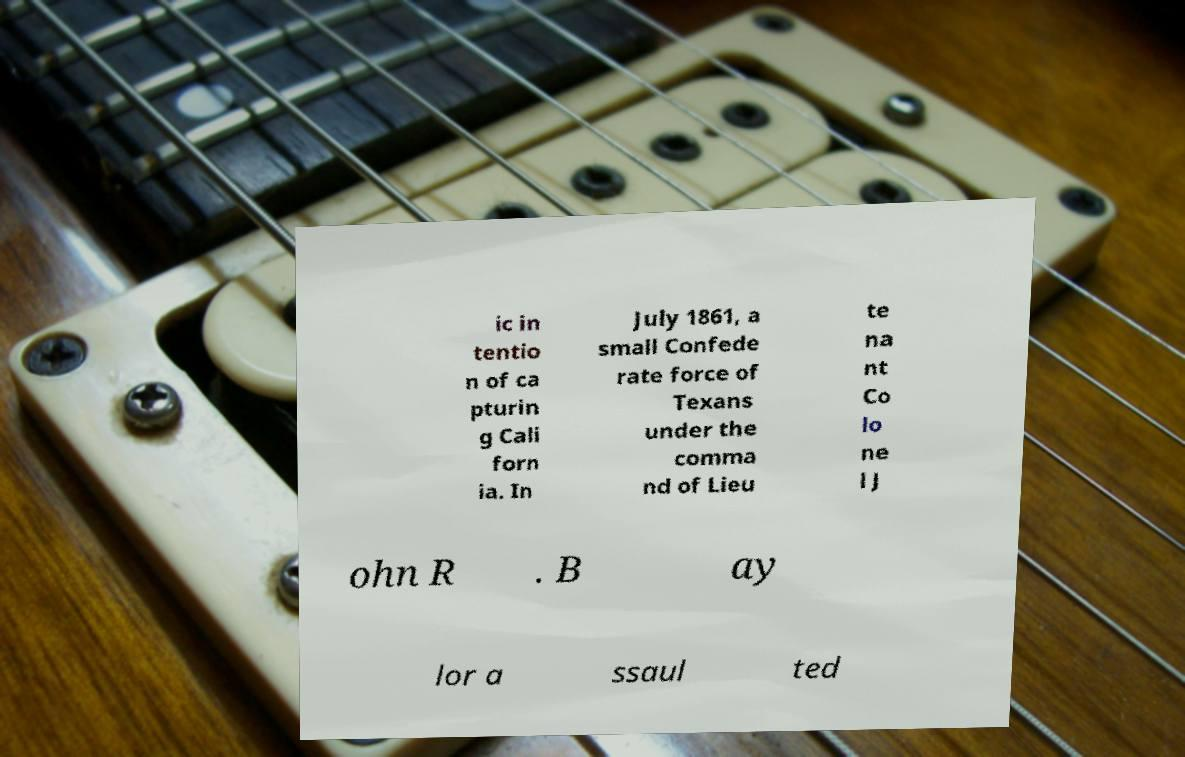I need the written content from this picture converted into text. Can you do that? ic in tentio n of ca pturin g Cali forn ia. In July 1861, a small Confede rate force of Texans under the comma nd of Lieu te na nt Co lo ne l J ohn R . B ay lor a ssaul ted 